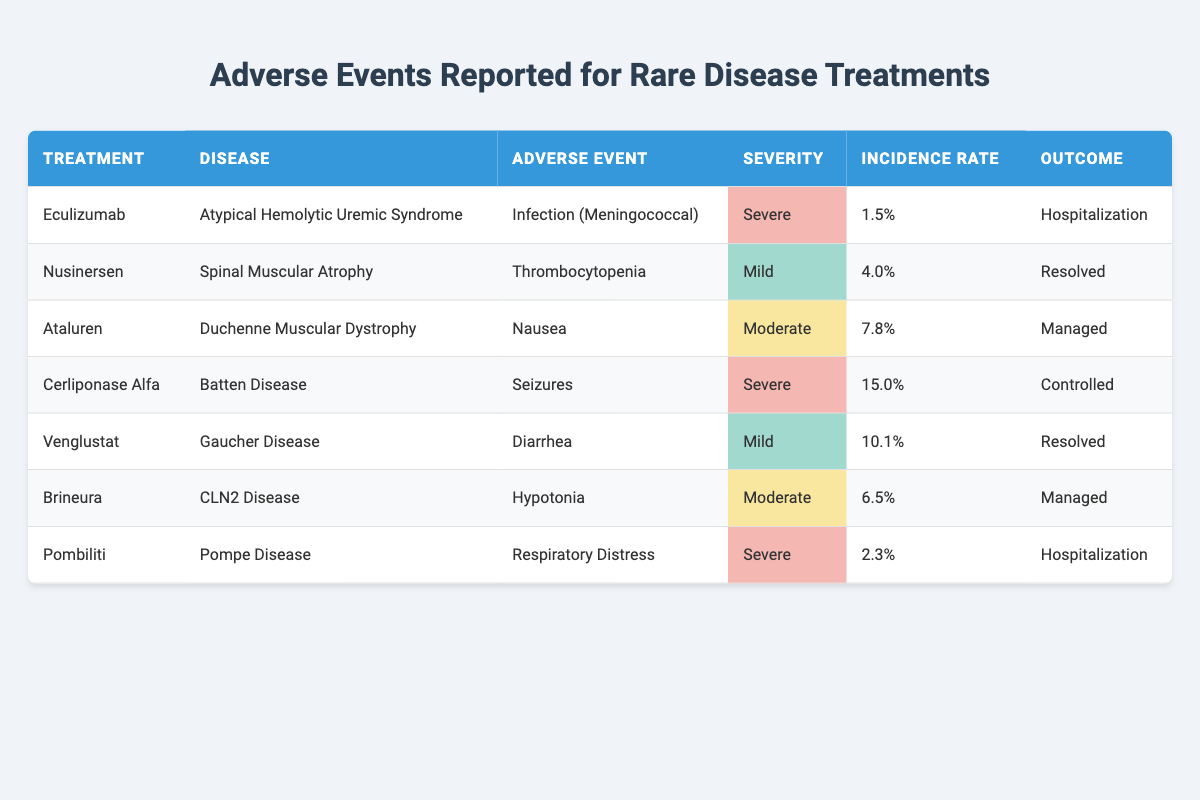What is the adverse event reported for the treatment Eculizumab? The table lists Eculizumab as a treatment for Atypical Hemolytic Uremic Syndrome and the associated adverse event is Infection (Meningococcal).
Answer: Infection (Meningococcal) How many treatments have a severe adverse event? There are three treatments with a severe adverse event: Eculizumab, Cerliponase Alfa, and Pombiliti.
Answer: 3 What is the incidence rate of adverse events for Nusinersen? The incidence rate for Nusinersen, which treats Spinal Muscular Atrophy, is 4.0% as stated in the table.
Answer: 4.0% Which treatment has the highest incidence rate and what is that rate? Cerliponase Alfa has the highest incidence rate at 15.0%, as observed in the table.
Answer: 15.0% Is the outcome of the adverse event for Brineura considered resolved? No, the outcome for Brineura indicates that the adverse event of Hypotonia is managed and not resolved.
Answer: No What is the average incidence rate of adverse events reported for the treatments listed? The incidence rates to average are: 1.5%, 4.0%, 7.8%, 15.0%, 10.1%, 6.5%, and 2.3%. Summing these up gives 47.2% and dividing by 7 (the number of treatments) gives an average of approximately 6.74%.
Answer: 6.74% Which mild adverse event had the highest incidence rate? The mild adverse event is Diarrhea from Venglustat with an incidence rate of 10.1%, which is higher than Thrombocytopenia.
Answer: Diarrhea Does any treatment result in hospitalization as an outcome for adverse events? Yes, the treatments Eculizumab and Pombiliti both have hospitalization as the outcome for their adverse events.
Answer: Yes 